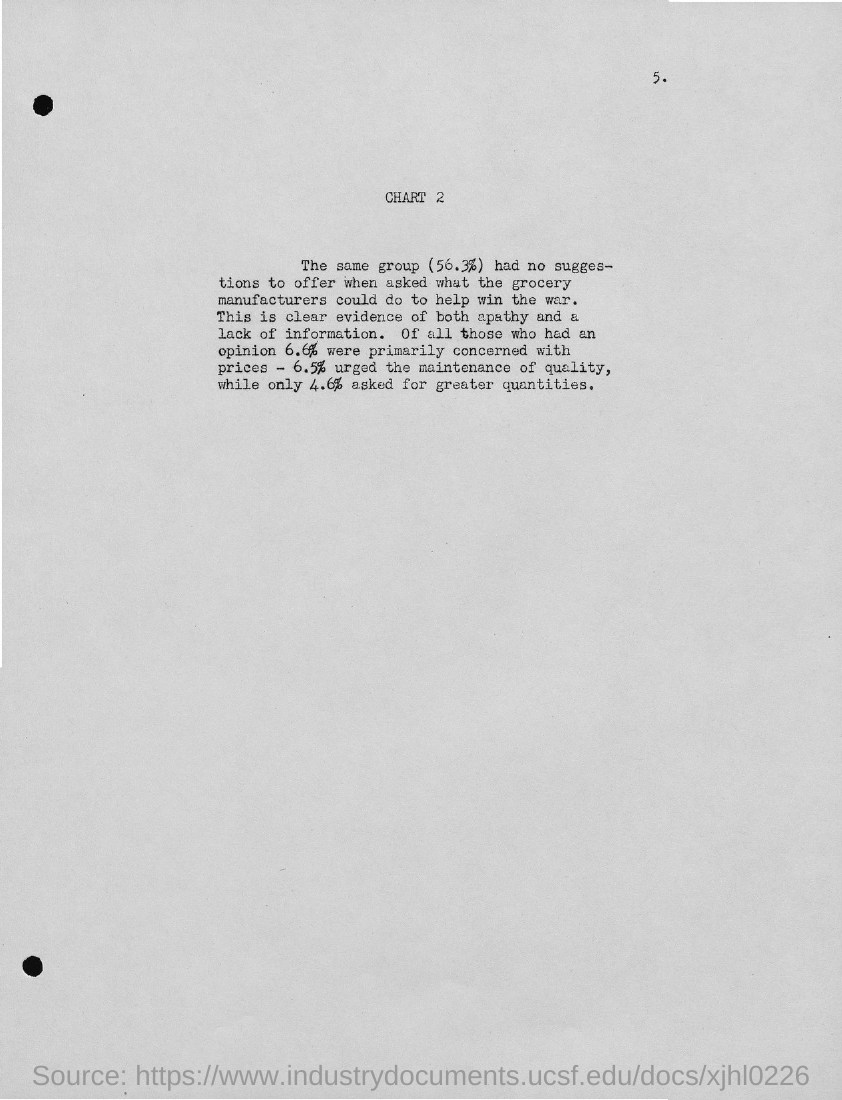What is the page number?
Your answer should be compact. 5. What is the chart number?
Your answer should be compact. 2. 